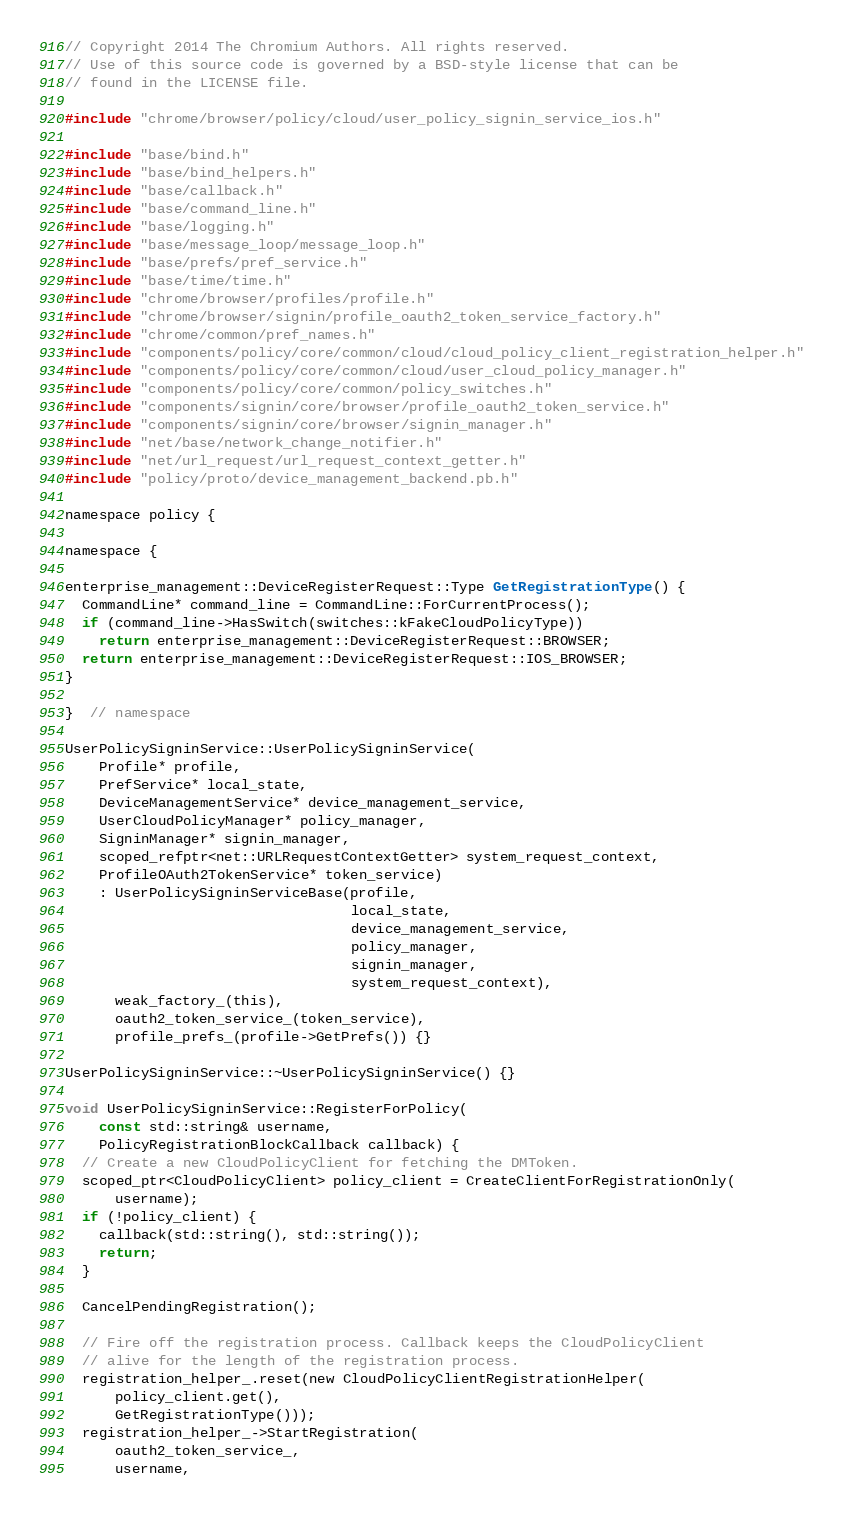<code> <loc_0><loc_0><loc_500><loc_500><_ObjectiveC_>// Copyright 2014 The Chromium Authors. All rights reserved.
// Use of this source code is governed by a BSD-style license that can be
// found in the LICENSE file.

#include "chrome/browser/policy/cloud/user_policy_signin_service_ios.h"

#include "base/bind.h"
#include "base/bind_helpers.h"
#include "base/callback.h"
#include "base/command_line.h"
#include "base/logging.h"
#include "base/message_loop/message_loop.h"
#include "base/prefs/pref_service.h"
#include "base/time/time.h"
#include "chrome/browser/profiles/profile.h"
#include "chrome/browser/signin/profile_oauth2_token_service_factory.h"
#include "chrome/common/pref_names.h"
#include "components/policy/core/common/cloud/cloud_policy_client_registration_helper.h"
#include "components/policy/core/common/cloud/user_cloud_policy_manager.h"
#include "components/policy/core/common/policy_switches.h"
#include "components/signin/core/browser/profile_oauth2_token_service.h"
#include "components/signin/core/browser/signin_manager.h"
#include "net/base/network_change_notifier.h"
#include "net/url_request/url_request_context_getter.h"
#include "policy/proto/device_management_backend.pb.h"

namespace policy {

namespace {

enterprise_management::DeviceRegisterRequest::Type GetRegistrationType() {
  CommandLine* command_line = CommandLine::ForCurrentProcess();
  if (command_line->HasSwitch(switches::kFakeCloudPolicyType))
    return enterprise_management::DeviceRegisterRequest::BROWSER;
  return enterprise_management::DeviceRegisterRequest::IOS_BROWSER;
}

}  // namespace

UserPolicySigninService::UserPolicySigninService(
    Profile* profile,
    PrefService* local_state,
    DeviceManagementService* device_management_service,
    UserCloudPolicyManager* policy_manager,
    SigninManager* signin_manager,
    scoped_refptr<net::URLRequestContextGetter> system_request_context,
    ProfileOAuth2TokenService* token_service)
    : UserPolicySigninServiceBase(profile,
                                  local_state,
                                  device_management_service,
                                  policy_manager,
                                  signin_manager,
                                  system_request_context),
      weak_factory_(this),
      oauth2_token_service_(token_service),
      profile_prefs_(profile->GetPrefs()) {}

UserPolicySigninService::~UserPolicySigninService() {}

void UserPolicySigninService::RegisterForPolicy(
    const std::string& username,
    PolicyRegistrationBlockCallback callback) {
  // Create a new CloudPolicyClient for fetching the DMToken.
  scoped_ptr<CloudPolicyClient> policy_client = CreateClientForRegistrationOnly(
      username);
  if (!policy_client) {
    callback(std::string(), std::string());
    return;
  }

  CancelPendingRegistration();

  // Fire off the registration process. Callback keeps the CloudPolicyClient
  // alive for the length of the registration process.
  registration_helper_.reset(new CloudPolicyClientRegistrationHelper(
      policy_client.get(),
      GetRegistrationType()));
  registration_helper_->StartRegistration(
      oauth2_token_service_,
      username,</code> 